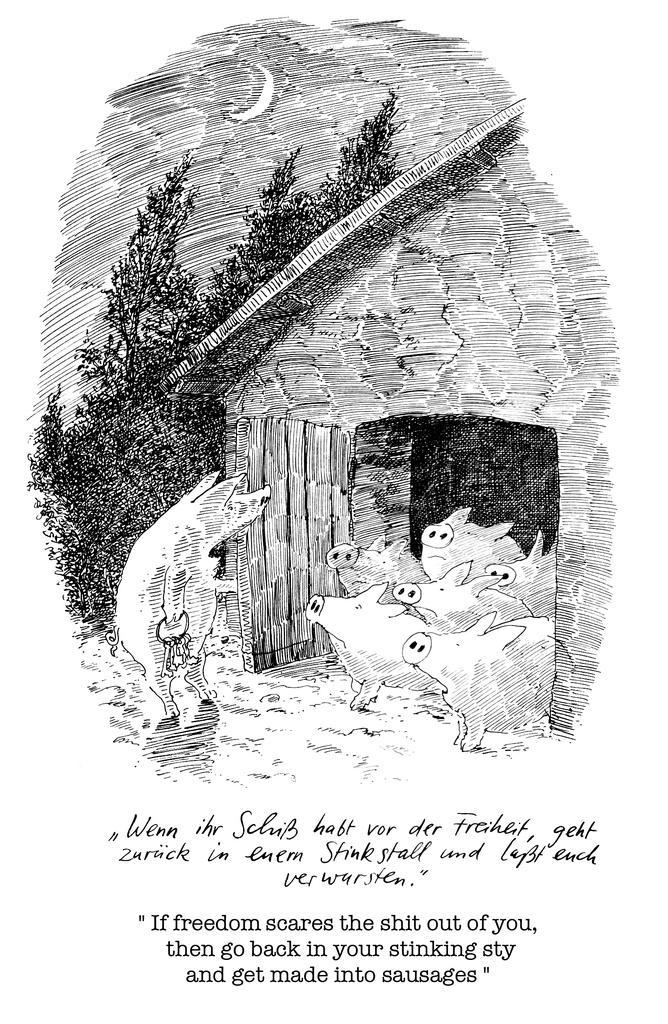Can you describe this image briefly? In this image we can see the art of a hut, pigs, trees and also the moon. We can also see the text at the bottom and the background of the image is is white color. 